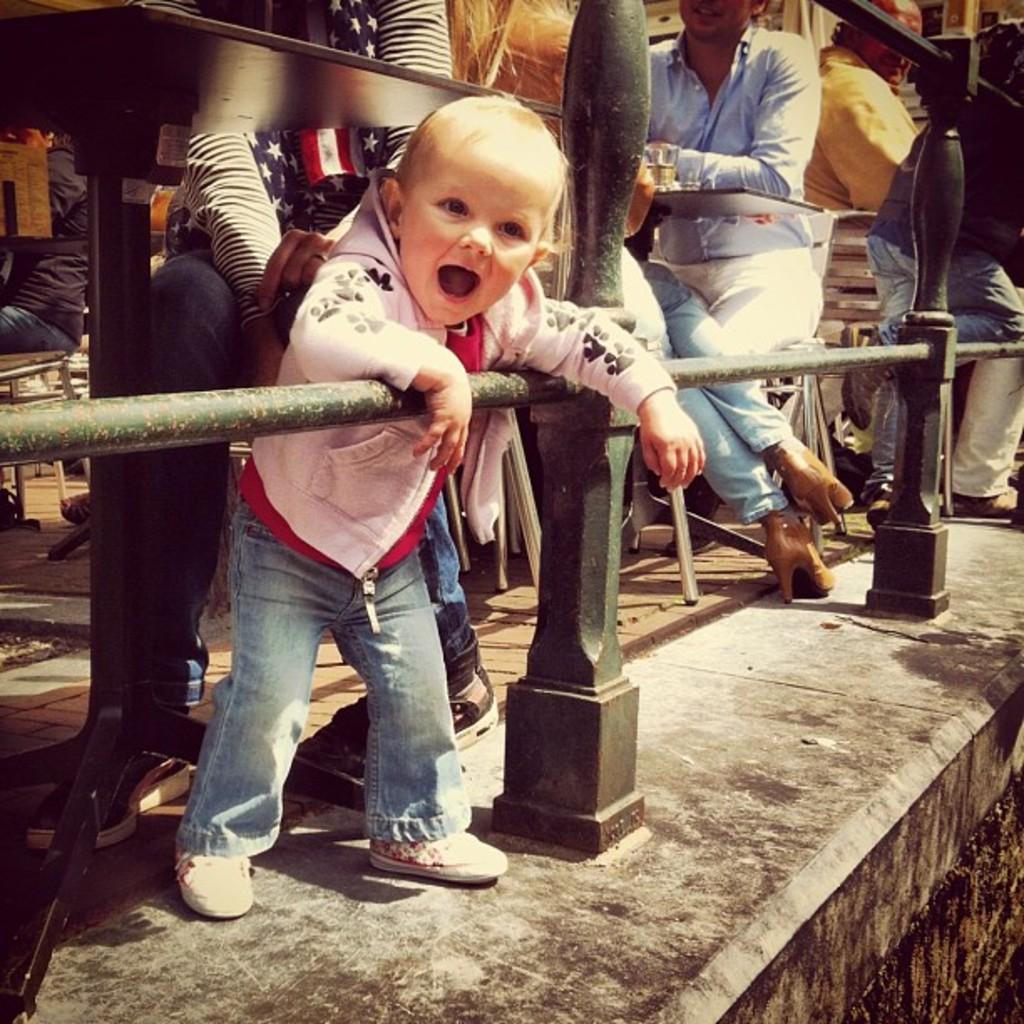Could you give a brief overview of what you see in this image? In this image we can see the pillar fence. In the background we can see the persons sitting on the chairs in front of the tables. We can also see the glass. 